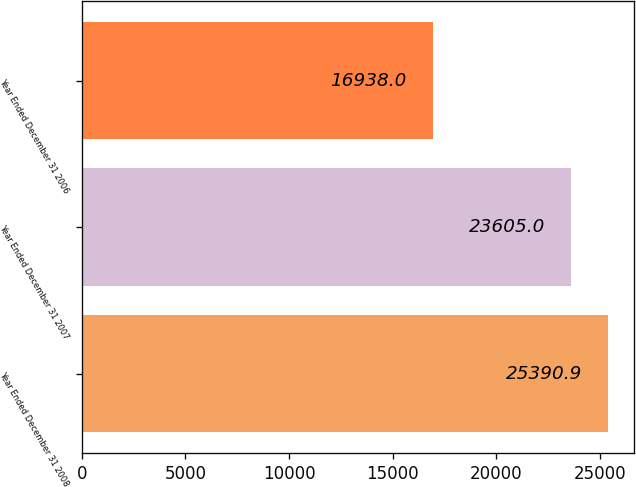Convert chart. <chart><loc_0><loc_0><loc_500><loc_500><bar_chart><fcel>Year Ended December 31 2008<fcel>Year Ended December 31 2007<fcel>Year Ended December 31 2006<nl><fcel>25390.9<fcel>23605<fcel>16938<nl></chart> 